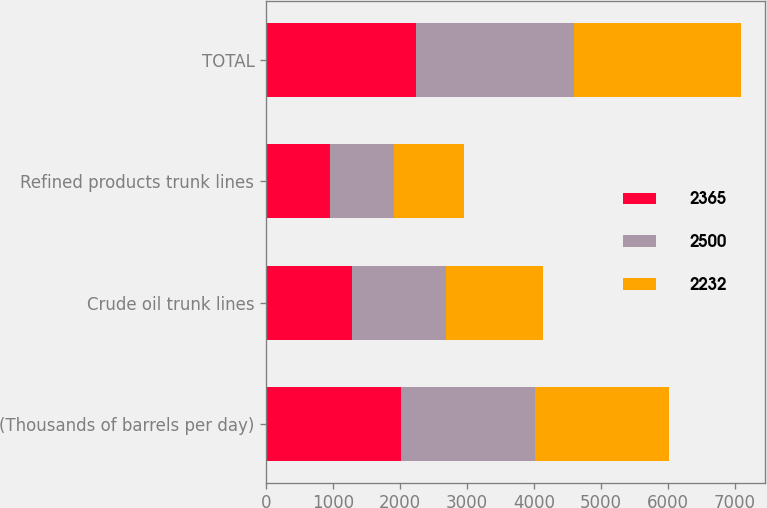Convert chart. <chart><loc_0><loc_0><loc_500><loc_500><stacked_bar_chart><ecel><fcel>(Thousands of barrels per day)<fcel>Crude oil trunk lines<fcel>Refined products trunk lines<fcel>TOTAL<nl><fcel>2365<fcel>2009<fcel>1279<fcel>953<fcel>2232<nl><fcel>2500<fcel>2008<fcel>1405<fcel>960<fcel>2365<nl><fcel>2232<fcel>2007<fcel>1451<fcel>1049<fcel>2500<nl></chart> 